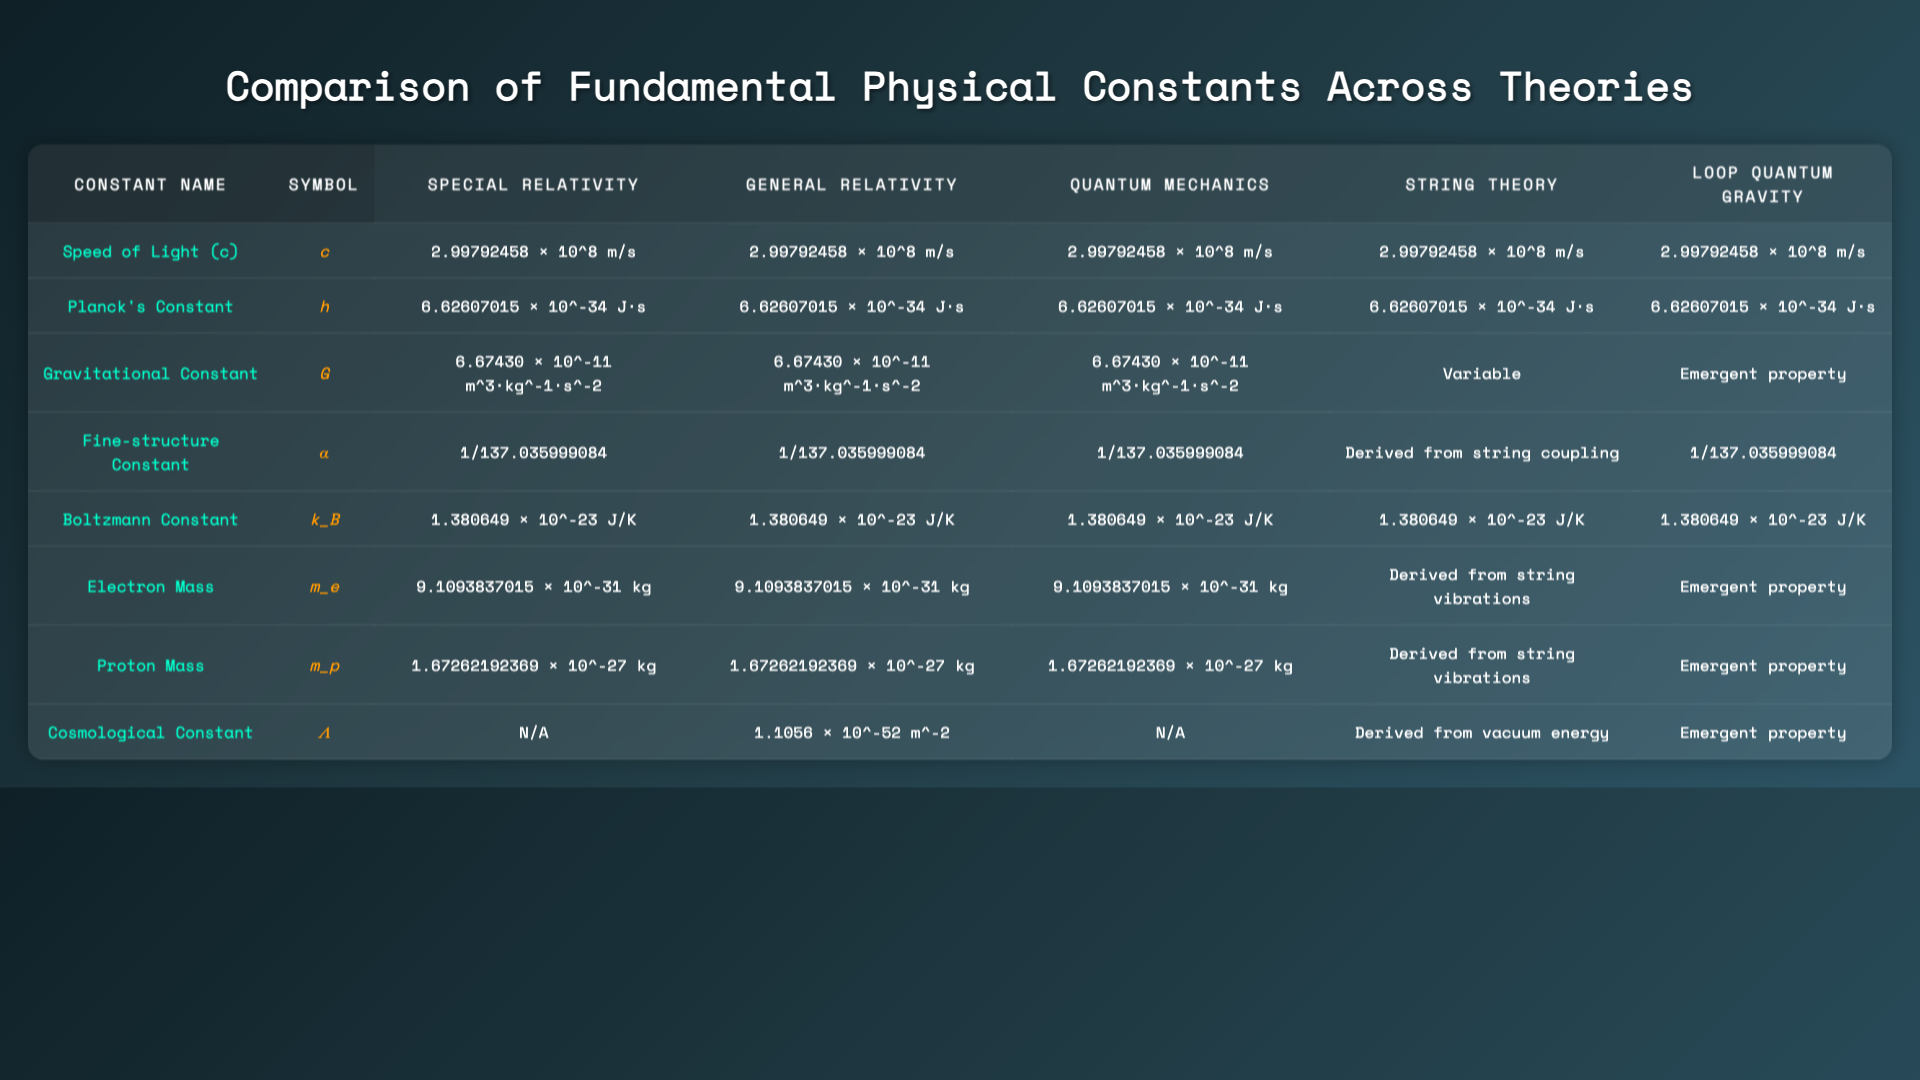What is the value of Planck's Constant according to Quantum Mechanics? The table shows that Planck's Constant is the same across all theories, and for Quantum Mechanics, it is listed as 6.62607015 × 10^-34 J⋅s.
Answer: 6.62607015 × 10^-34 J⋅s Is the value of the Gravitational Constant the same in Special and General Relativity? Both the Special Relativity and General Relativity columns have the same value for the Gravitational Constant, which is 6.67430 × 10^-11 m^3⋅kg^-1⋅s^-2.
Answer: Yes What is the difference in representation of the Gravitational Constant between String Theory and other theories? The Gravitational Constant is represented as a specific value in Special and General Relativity, Quantum Mechanics, while in String Theory it is labeled as "Variable" and as "Emergent property" in Loop Quantum Gravity, indicating variability.
Answer: Variable According to the table, does String Theory provide a definite value for the Fine Structure Constant? The Fine Structure Constant is given as "Derived from string coupling" for String Theory, which does not provide a definite numerical value like the other theories do.
Answer: No What is the total amount of constant values for Electron Mass across all theories? The Electron Mass is consistently listed as 9.1093837015 × 10^-31 kg across Special Relativity, General Relativity, Quantum Mechanics, and for String Theory it’s derived, while it’s emergent in Loop Quantum Gravity. The quantity does not change, so it remains the same.
Answer: 9.1093837015 × 10^-31 kg How many constants are represented as emergent properties in Loop Quantum Gravity? The table shows that the Gravitational Constant, Electron Mass, Proton Mass, and Cosmological Constant all have the string "Emergent property" in Loop Quantum Gravity, totaling four such constants.
Answer: 4 Is there a constant in the table that is not applicable (N/A) for Special Relativity? The table indicates that the Cosmological Constant is listed as "N/A" for Special Relativity, suggesting it is not applicable in that context.
Answer: Yes Which of the constants has a varied representation across different theories? The Gravitational Constant is unique in that it has a specific value in some theories, but is labeled "Variable" in String Theory and "Emergent property" in Loop Quantum Gravity, indicating it does not have a consistent numerical representation.
Answer: Gravitational Constant What is the average value of the Speed of Light across all listed theories? The Speed of Light retains the same value of 2.99792458 × 10^8 m/s across Special Relativity, General Relativity, Quantum Mechanics, String Theory, and Loop Quantum Gravity. Therefore, the average equals that value.
Answer: 2.99792458 × 10^8 m/s 